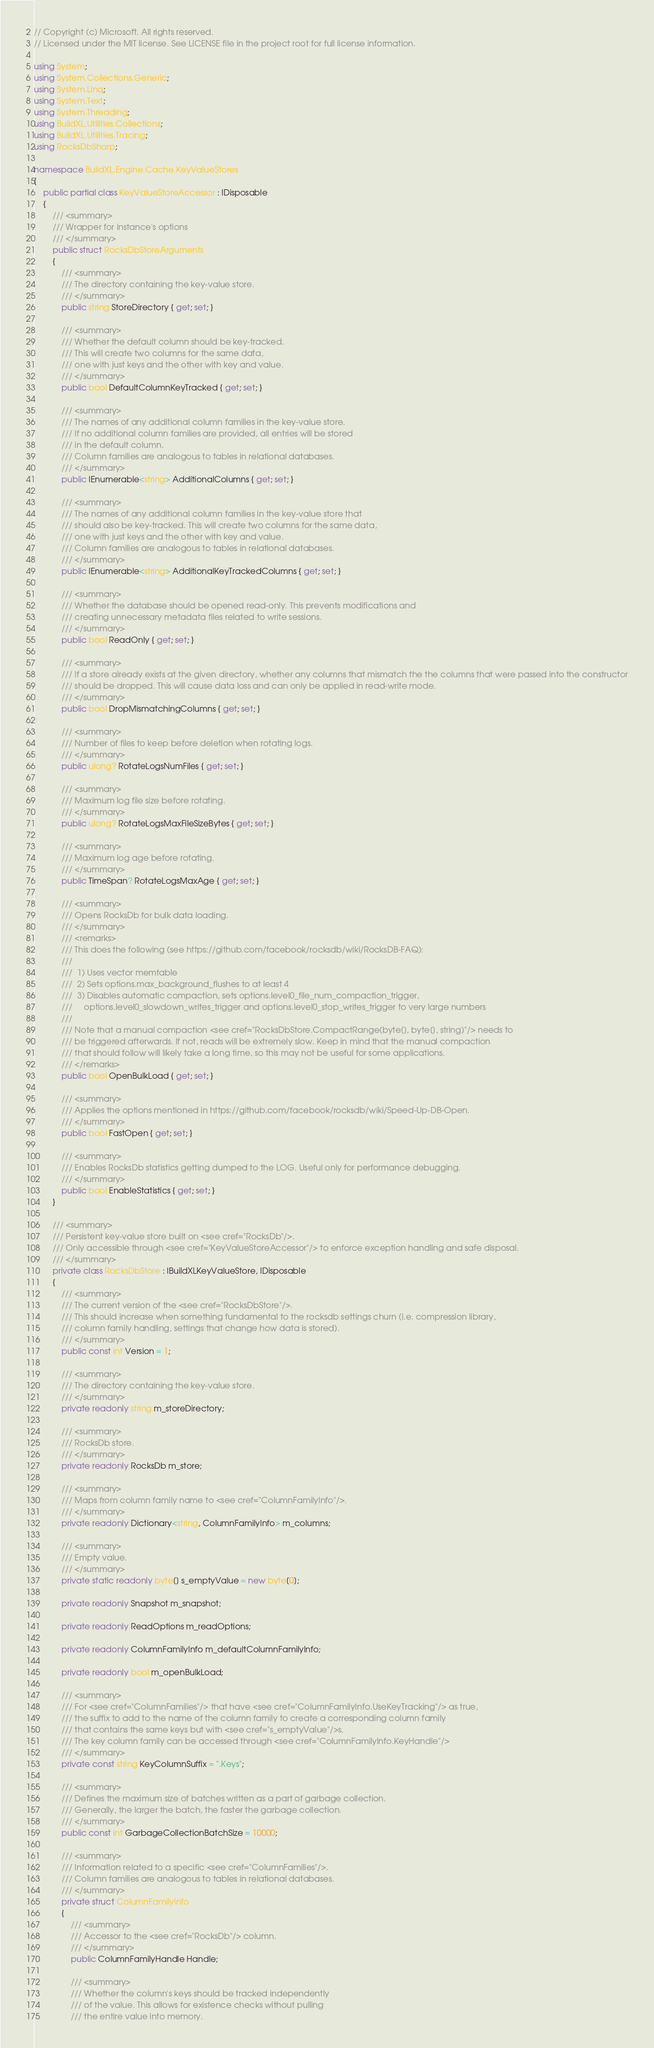Convert code to text. <code><loc_0><loc_0><loc_500><loc_500><_C#_>// Copyright (c) Microsoft. All rights reserved.
// Licensed under the MIT license. See LICENSE file in the project root for full license information.

using System;
using System.Collections.Generic;
using System.Linq;
using System.Text;
using System.Threading;
using BuildXL.Utilities.Collections;
using BuildXL.Utilities.Tracing;
using RocksDbSharp;

namespace BuildXL.Engine.Cache.KeyValueStores
{
    public partial class KeyValueStoreAccessor : IDisposable
    {
        /// <summary>
        /// Wrapper for instance's options
        /// </summary>
        public struct RocksDbStoreArguments
        {
            /// <summary>
            /// The directory containing the key-value store.
            /// </summary>
            public string StoreDirectory { get; set; }

            /// <summary>
            /// Whether the default column should be key-tracked.
            /// This will create two columns for the same data,
            /// one with just keys and the other with key and value.
            /// </summary>
            public bool DefaultColumnKeyTracked { get; set; }

            /// <summary>
            /// The names of any additional column families in the key-value store.
            /// If no additional column families are provided, all entries will be stored
            /// in the default column.
            /// Column families are analogous to tables in relational databases.
            /// </summary>
            public IEnumerable<string> AdditionalColumns { get; set; }

            /// <summary>
            /// The names of any additional column families in the key-value store that
            /// should also be key-tracked. This will create two columns for the same data,
            /// one with just keys and the other with key and value.
            /// Column families are analogous to tables in relational databases.
            /// </summary>
            public IEnumerable<string> AdditionalKeyTrackedColumns { get; set; }

            /// <summary>
            /// Whether the database should be opened read-only. This prevents modifications and
            /// creating unnecessary metadata files related to write sessions.
            /// </summary>
            public bool ReadOnly { get; set; }

            /// <summary>
            /// If a store already exists at the given directory, whether any columns that mismatch the the columns that were passed into the constructor
            /// should be dropped. This will cause data loss and can only be applied in read-write mode.
            /// </summary>
            public bool DropMismatchingColumns { get; set; }

            /// <summary>
            /// Number of files to keep before deletion when rotating logs.
            /// </summary>
            public ulong? RotateLogsNumFiles { get; set; }

            /// <summary>
            /// Maximum log file size before rotating.
            /// </summary>
            public ulong? RotateLogsMaxFileSizeBytes { get; set; }

            /// <summary>
            /// Maximum log age before rotating.
            /// </summary>
            public TimeSpan? RotateLogsMaxAge { get; set; }

            /// <summary>
            /// Opens RocksDb for bulk data loading.
            /// </summary>
            /// <remarks>
            /// This does the following (see https://github.com/facebook/rocksdb/wiki/RocksDB-FAQ):
            /// 
            ///  1) Uses vector memtable
            ///  2) Sets options.max_background_flushes to at least 4
            ///  3) Disables automatic compaction, sets options.level0_file_num_compaction_trigger, 
            ///     options.level0_slowdown_writes_trigger and options.level0_stop_writes_trigger to very large numbers
            ///     
            /// Note that a manual compaction <see cref="RocksDbStore.CompactRange(byte[], byte[], string)"/> needs to 
            /// be triggered afterwards. If not, reads will be extremely slow. Keep in mind that the manual compaction
            /// that should follow will likely take a long time, so this may not be useful for some applications.
            /// </remarks>
            public bool OpenBulkLoad { get; set; }

            /// <summary>
            /// Applies the options mentioned in https://github.com/facebook/rocksdb/wiki/Speed-Up-DB-Open.
            /// </summary>
            public bool FastOpen { get; set; }

            /// <summary>
            /// Enables RocksDb statistics getting dumped to the LOG. Useful only for performance debugging.
            /// </summary>
            public bool EnableStatistics { get; set; }
        }

        /// <summary>
        /// Persistent key-value store built on <see cref="RocksDb"/>.
        /// Only accessible through <see cref="KeyValueStoreAccessor"/> to enforce exception handling and safe disposal.
        /// </summary>
        private class RocksDbStore : IBuildXLKeyValueStore, IDisposable
        {
            /// <summary>
            /// The current version of the <see cref="RocksDbStore"/>.
            /// This should increase when something fundamental to the rocksdb settings churn (i.e. compression library,
            /// column family handling, settings that change how data is stored).
            /// </summary>
            public const int Version = 1;

            /// <summary>
            /// The directory containing the key-value store.
            /// </summary>
            private readonly string m_storeDirectory;

            /// <summary>
            /// RocksDb store.
            /// </summary>
            private readonly RocksDb m_store;

            /// <summary>
            /// Maps from column family name to <see cref="ColumnFamilyInfo"/>.
            /// </summary>
            private readonly Dictionary<string, ColumnFamilyInfo> m_columns;

            /// <summary>
            /// Empty value.
            /// </summary>
            private static readonly byte[] s_emptyValue = new byte[0];

            private readonly Snapshot m_snapshot;

            private readonly ReadOptions m_readOptions;

            private readonly ColumnFamilyInfo m_defaultColumnFamilyInfo;

            private readonly bool m_openBulkLoad;

            /// <summary>
            /// For <see cref="ColumnFamilies"/> that have <see cref="ColumnFamilyInfo.UseKeyTracking"/> as true,
            /// the suffix to add to the name of the column family to create a corresponding column family
            /// that contains the same keys but with <see cref="s_emptyValue"/>s.
            /// The key column family can be accessed through <see cref="ColumnFamilyInfo.KeyHandle"/>
            /// </summary>
            private const string KeyColumnSuffix = ".Keys";

            /// <summary>
            /// Defines the maximum size of batches written as a part of garbage collection.
            /// Generally, the larger the batch, the faster the garbage collection.
            /// </summary>
            public const int GarbageCollectionBatchSize = 10000;

            /// <summary>
            /// Information related to a specific <see cref="ColumnFamilies"/>.
            /// Column families are analogous to tables in relational databases.
            /// </summary>
            private struct ColumnFamilyInfo
            {
                /// <summary>
                /// Accessor to the <see cref="RocksDb"/> column.
                /// </summary>
                public ColumnFamilyHandle Handle;

                /// <summary>
                /// Whether the column's keys should be tracked independently
                /// of the value. This allows for existence checks without pulling
                /// the entire value into memory.</code> 